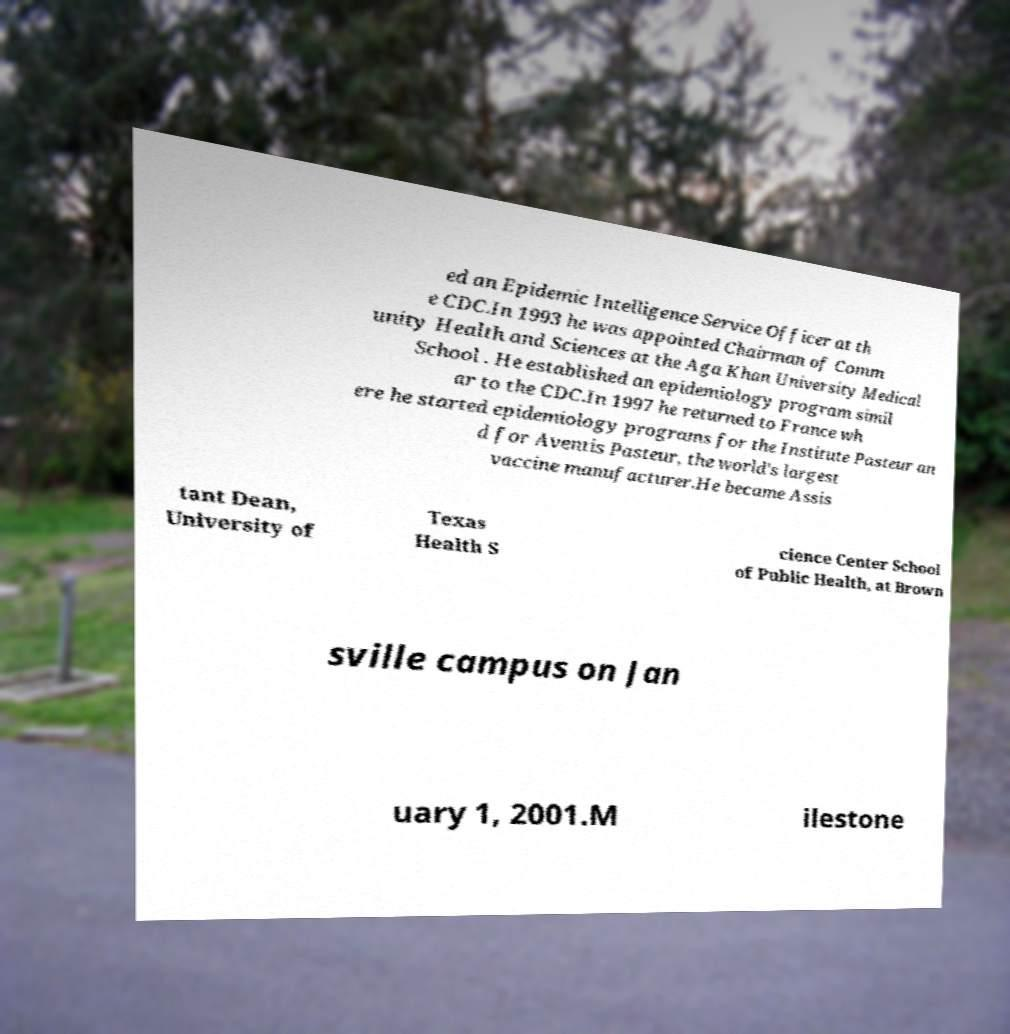Could you extract and type out the text from this image? ed an Epidemic Intelligence Service Officer at th e CDC.In 1993 he was appointed Chairman of Comm unity Health and Sciences at the Aga Khan University Medical School . He established an epidemiology program simil ar to the CDC.In 1997 he returned to France wh ere he started epidemiology programs for the Institute Pasteur an d for Aventis Pasteur, the world's largest vaccine manufacturer.He became Assis tant Dean, University of Texas Health S cience Center School of Public Health, at Brown sville campus on Jan uary 1, 2001.M ilestone 